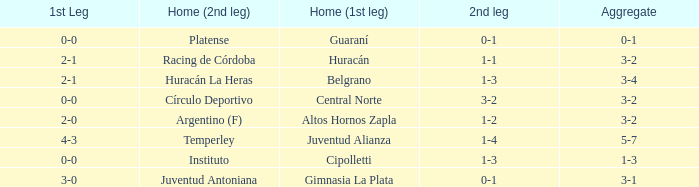Which team played their first leg at home with an aggregate score of 3-4? Belgrano. 